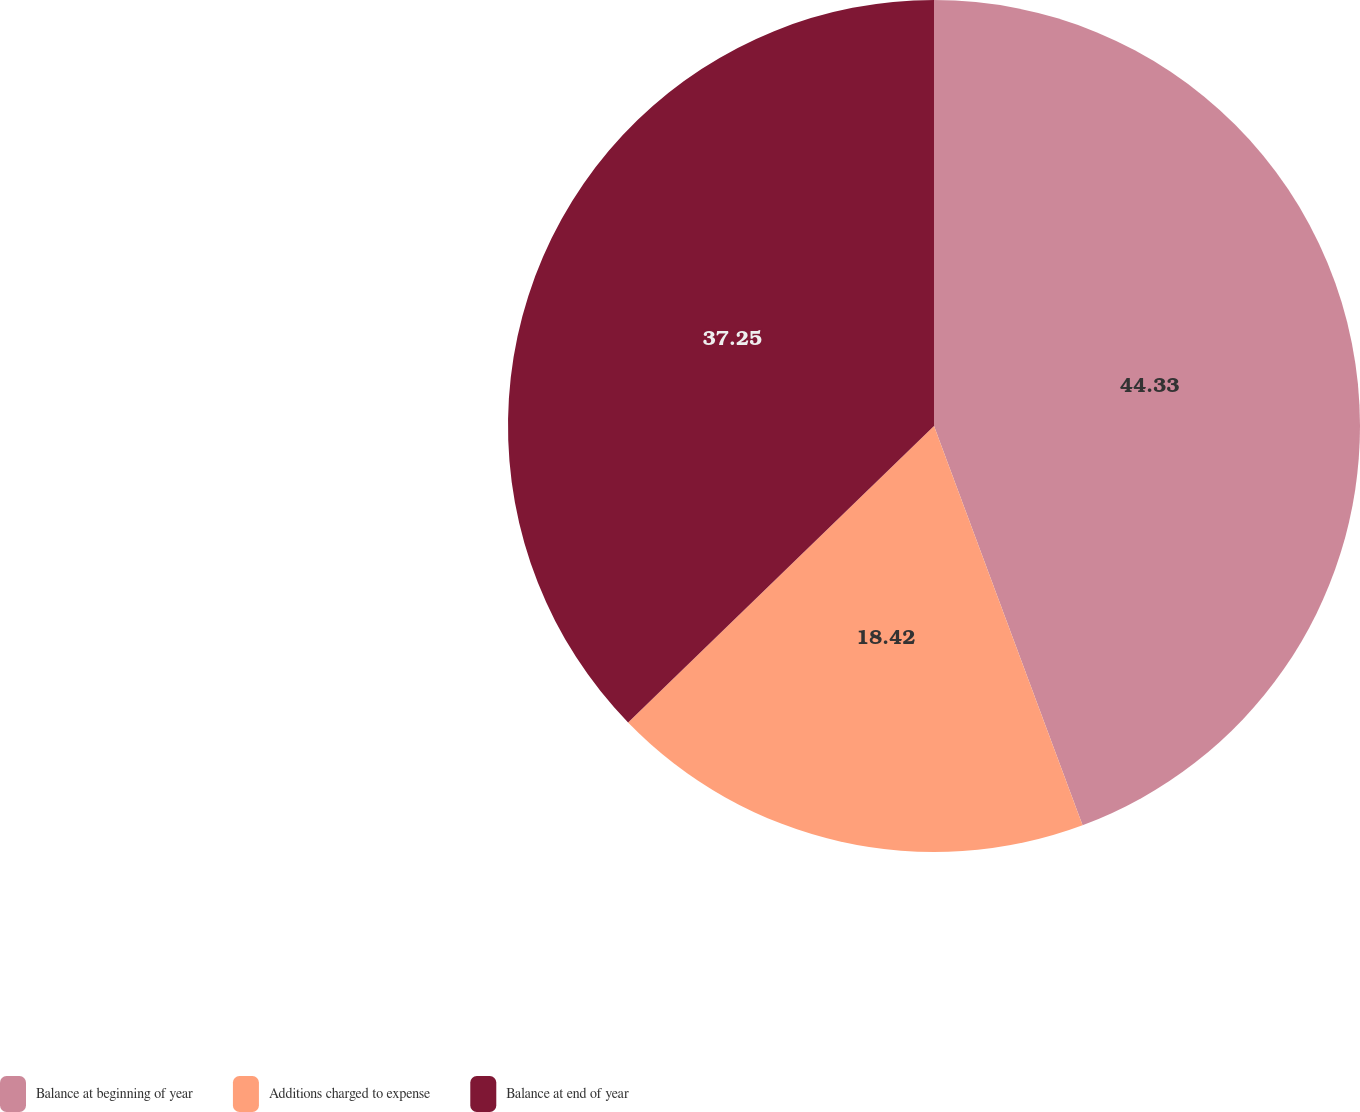<chart> <loc_0><loc_0><loc_500><loc_500><pie_chart><fcel>Balance at beginning of year<fcel>Additions charged to expense<fcel>Balance at end of year<nl><fcel>44.33%<fcel>18.42%<fcel>37.25%<nl></chart> 